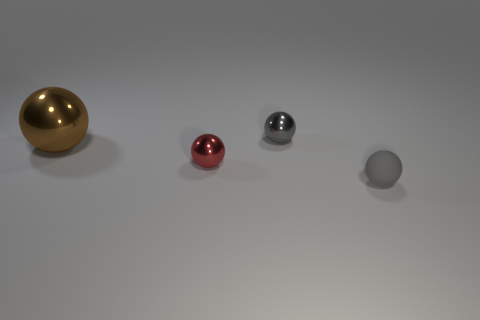What number of brown things are small objects or large rubber blocks?
Provide a short and direct response. 0. Are the large brown ball and the red sphere made of the same material?
Make the answer very short. Yes. There is a rubber sphere; what number of small things are to the left of it?
Ensure brevity in your answer.  2. What is the material of the thing that is in front of the big brown sphere and to the right of the red sphere?
Make the answer very short. Rubber. What number of balls are red objects or small objects?
Keep it short and to the point. 3. There is another red thing that is the same shape as the large object; what is it made of?
Keep it short and to the point. Metal. What size is the brown ball that is the same material as the red ball?
Make the answer very short. Large. There is a shiny thing that is to the right of the small red shiny object; is it the same shape as the gray object in front of the large metallic sphere?
Provide a succinct answer. Yes. There is a big sphere that is the same material as the small red object; what color is it?
Offer a terse response. Brown. There is a gray ball that is behind the tiny rubber sphere; does it have the same size as the shiny sphere in front of the big brown ball?
Ensure brevity in your answer.  Yes. 